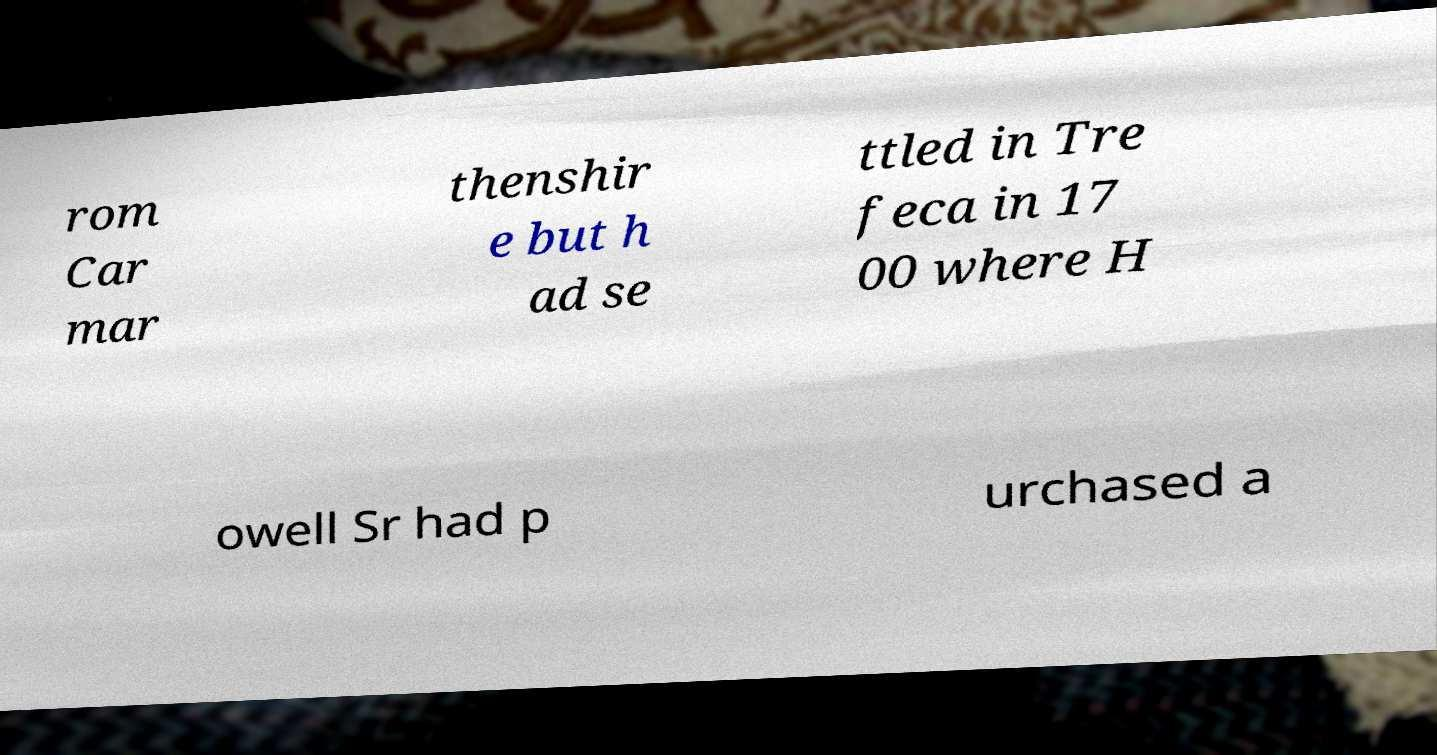Can you read and provide the text displayed in the image?This photo seems to have some interesting text. Can you extract and type it out for me? rom Car mar thenshir e but h ad se ttled in Tre feca in 17 00 where H owell Sr had p urchased a 